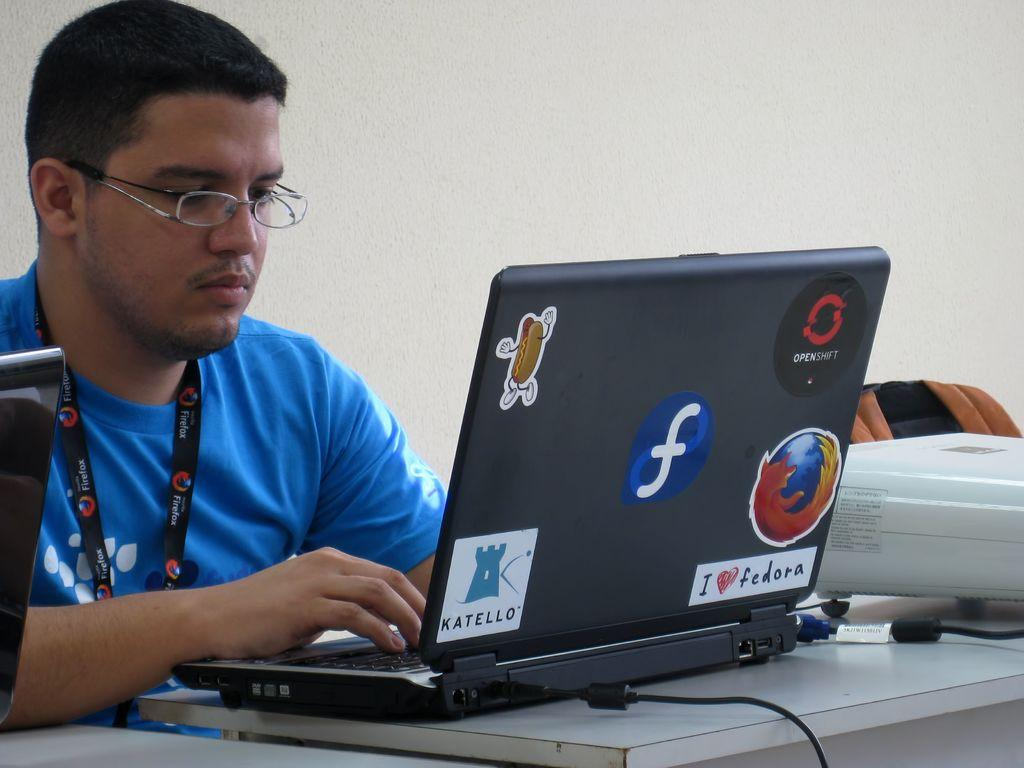<image>
Describe the image concisely. Man with glasses working on a laptop with a blue circle in the middle with a white f. 